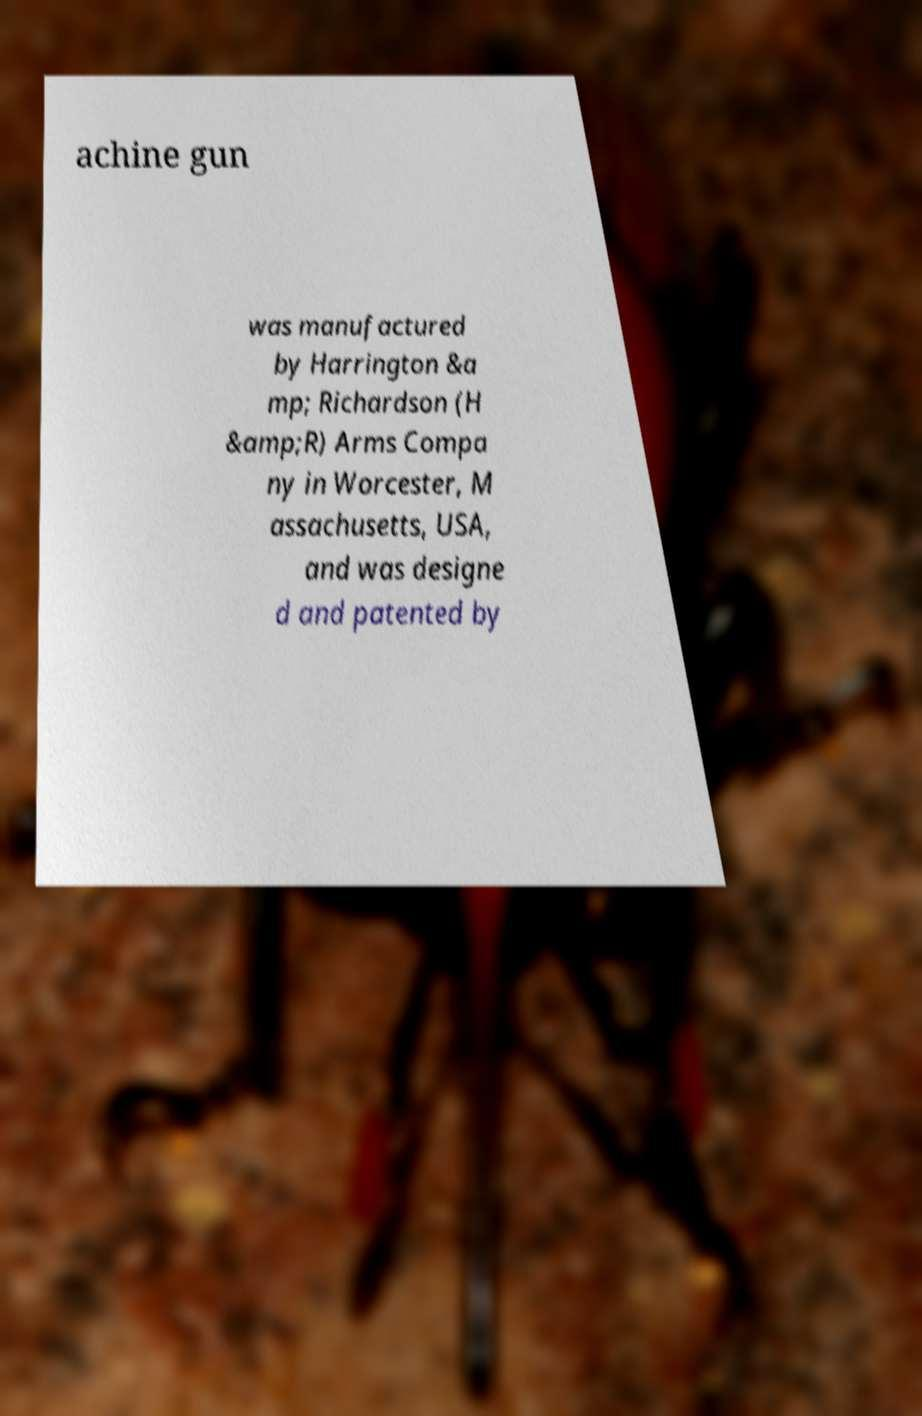What messages or text are displayed in this image? I need them in a readable, typed format. achine gun was manufactured by Harrington &a mp; Richardson (H &amp;R) Arms Compa ny in Worcester, M assachusetts, USA, and was designe d and patented by 